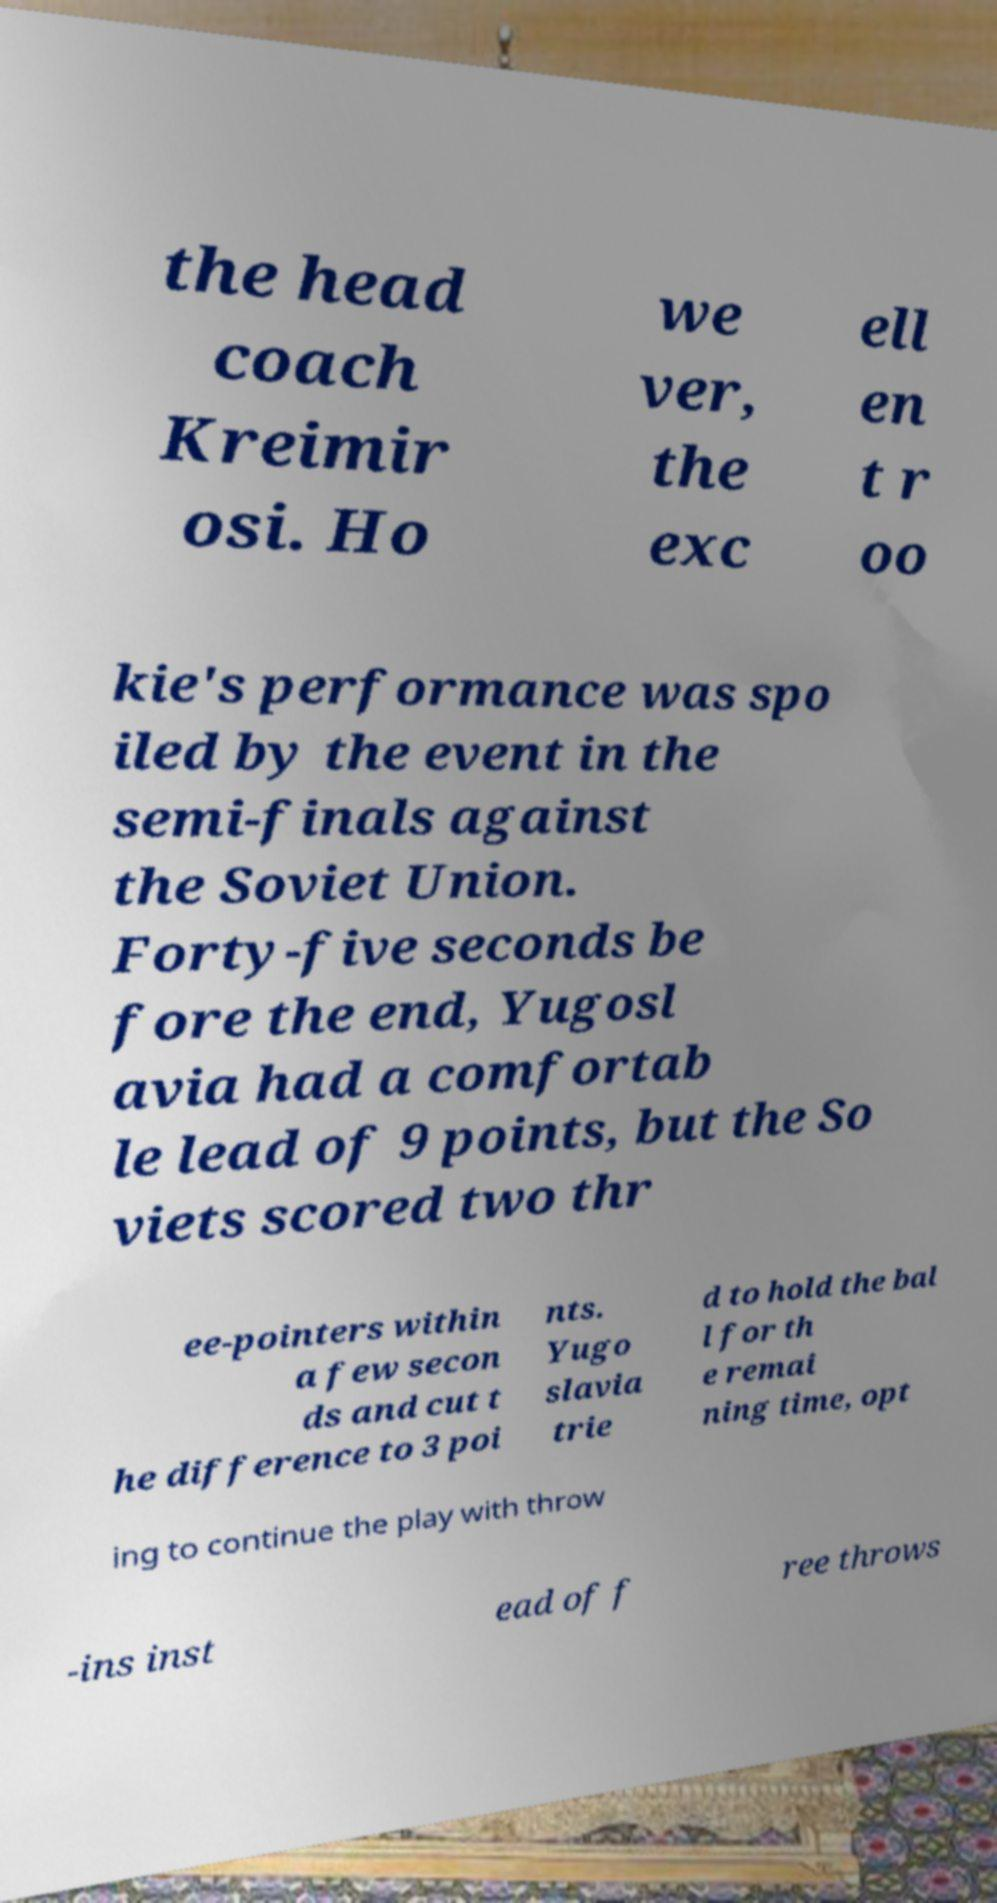Please identify and transcribe the text found in this image. the head coach Kreimir osi. Ho we ver, the exc ell en t r oo kie's performance was spo iled by the event in the semi-finals against the Soviet Union. Forty-five seconds be fore the end, Yugosl avia had a comfortab le lead of 9 points, but the So viets scored two thr ee-pointers within a few secon ds and cut t he difference to 3 poi nts. Yugo slavia trie d to hold the bal l for th e remai ning time, opt ing to continue the play with throw -ins inst ead of f ree throws 